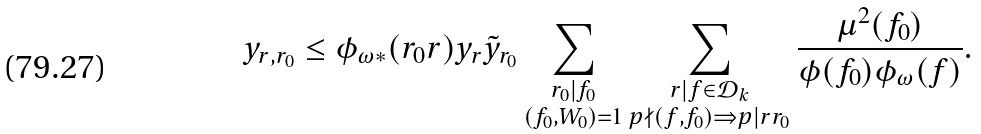<formula> <loc_0><loc_0><loc_500><loc_500>y _ { r , r _ { 0 } } \leq \phi _ { \omega * } ( r _ { 0 } r ) y _ { r } \tilde { y } _ { r _ { 0 } } \sum _ { \substack { r _ { 0 } | f _ { 0 } \\ ( f _ { 0 } , W _ { 0 } ) = 1 } } \sum _ { \substack { r | f \in \mathcal { D } _ { k } \\ p \nmid ( f , f _ { 0 } ) \Rightarrow p | r r _ { 0 } } } \frac { \mu ^ { 2 } ( f _ { 0 } ) } { \phi ( f _ { 0 } ) \phi _ { \omega } ( f ) } .</formula> 